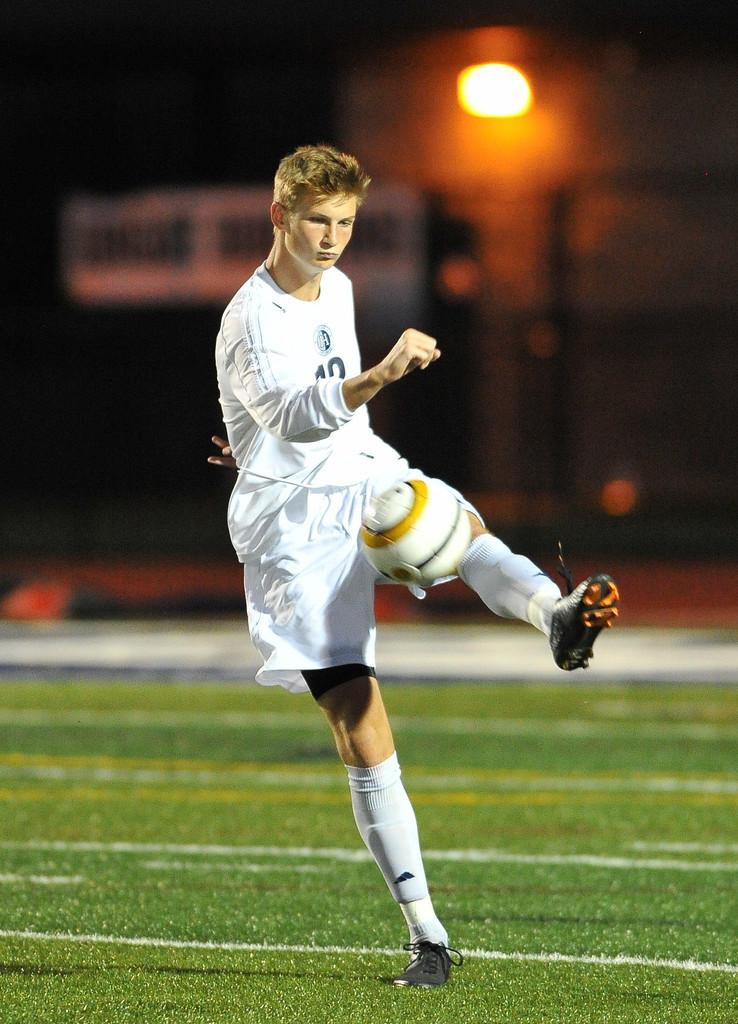What is the man in the image doing? The man is trying to kick a ball in the image. Where is the man standing? The man is standing on a ground in the image. What can be seen in the background of the image? There is a light and a name board in the background of the image. How would you describe the overall lighting in the image? The image appears to be dark. Is the man playing in a park or a square in the image? The image does not provide information about the specific location, such as a park or a square, where the man is playing. 